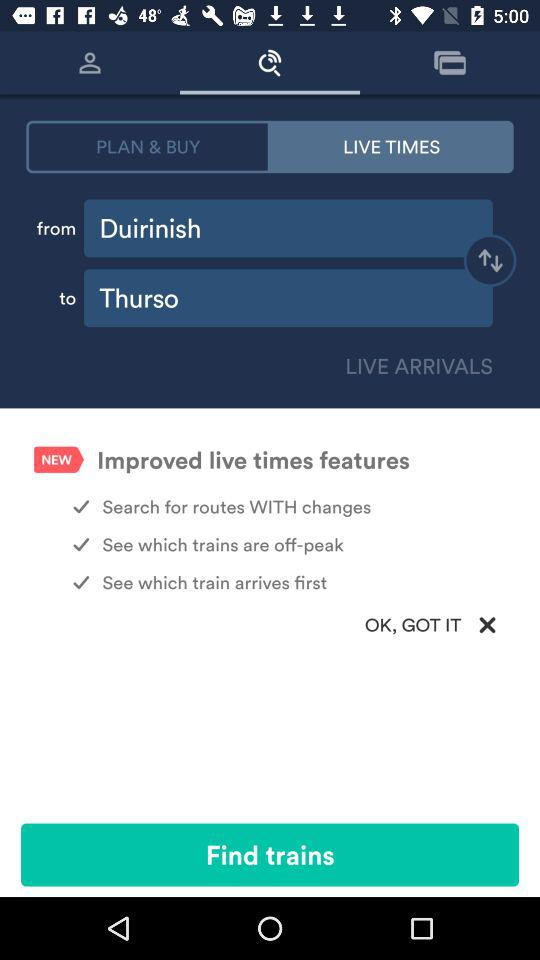What is the difference in minutes between the expected and on-time times for the train?
Answer the question using a single word or phrase. 12 